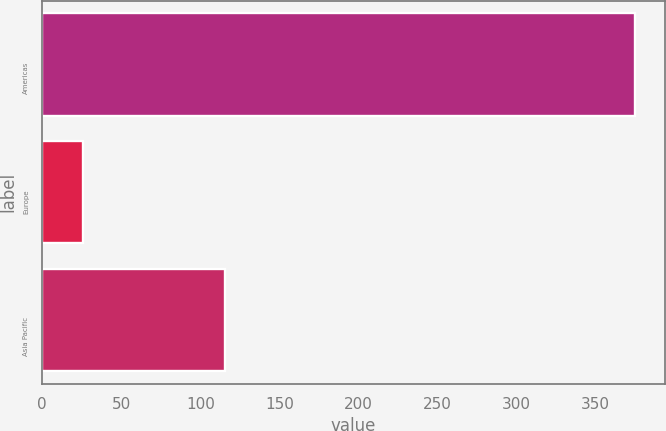<chart> <loc_0><loc_0><loc_500><loc_500><bar_chart><fcel>Americas<fcel>Europe<fcel>Asia Pacific<nl><fcel>374.9<fcel>25.9<fcel>115.8<nl></chart> 